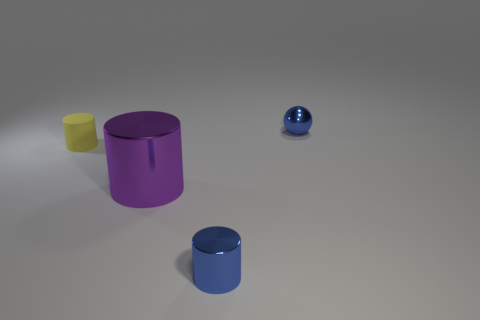What is the texture and color of the object farthest from the camera? The object farthest from the camera appears to have a smooth, reflective texture and is blue in color. 